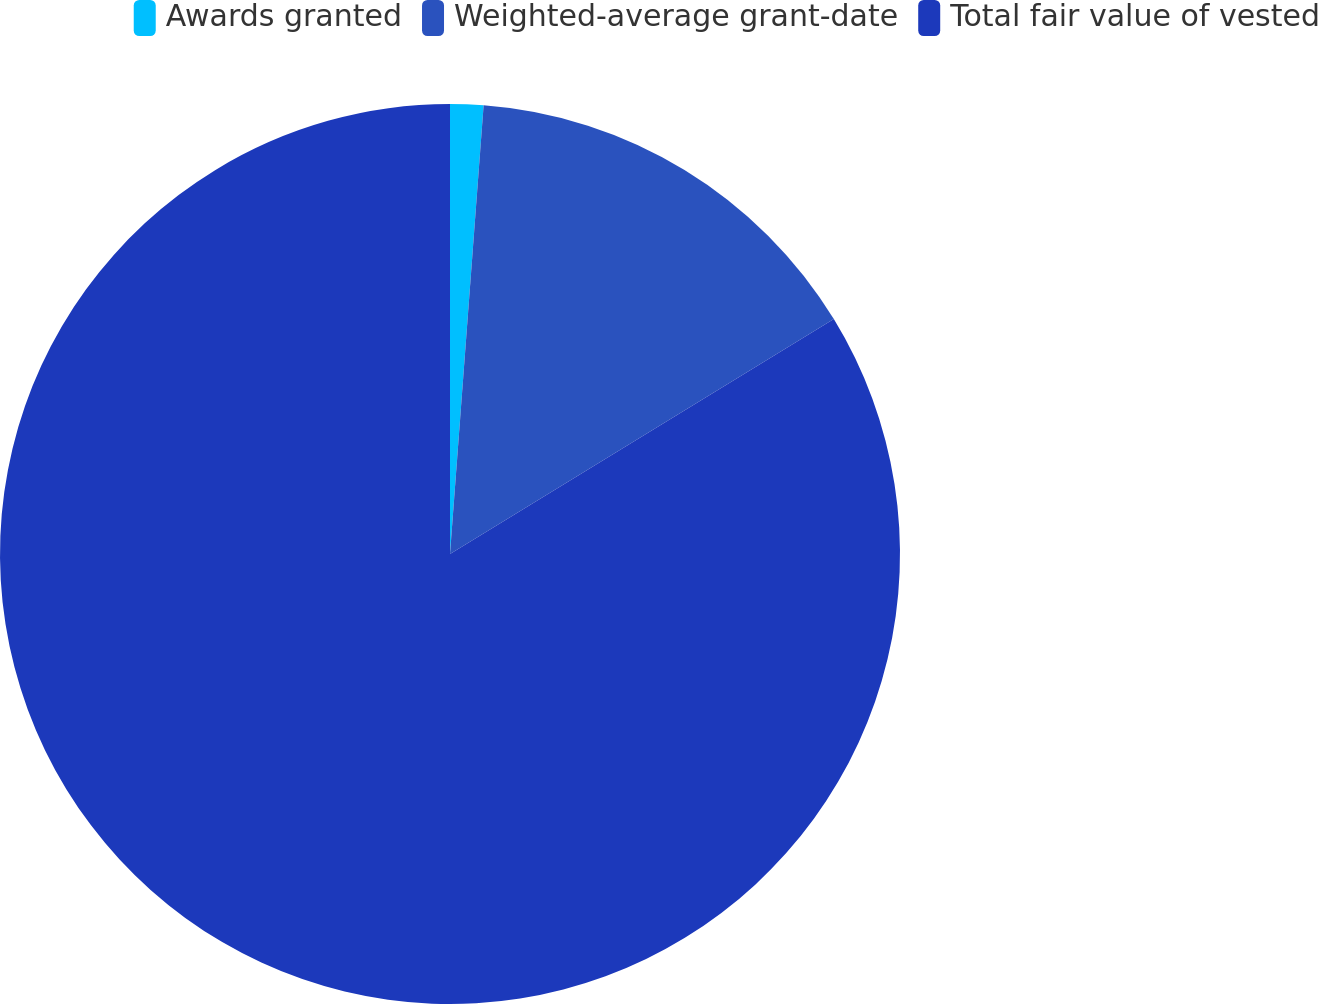Convert chart to OTSL. <chart><loc_0><loc_0><loc_500><loc_500><pie_chart><fcel>Awards granted<fcel>Weighted-average grant-date<fcel>Total fair value of vested<nl><fcel>1.19%<fcel>15.07%<fcel>83.74%<nl></chart> 